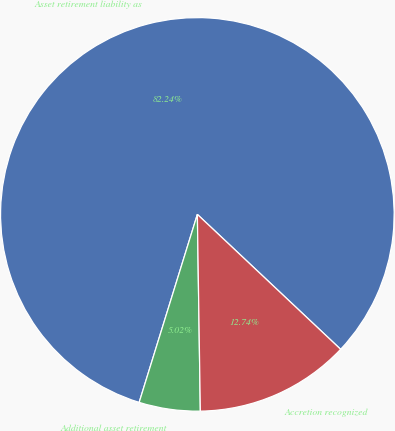Convert chart. <chart><loc_0><loc_0><loc_500><loc_500><pie_chart><fcel>Asset retirement liability as<fcel>Additional asset retirement<fcel>Accretion recognized<nl><fcel>82.25%<fcel>5.02%<fcel>12.74%<nl></chart> 